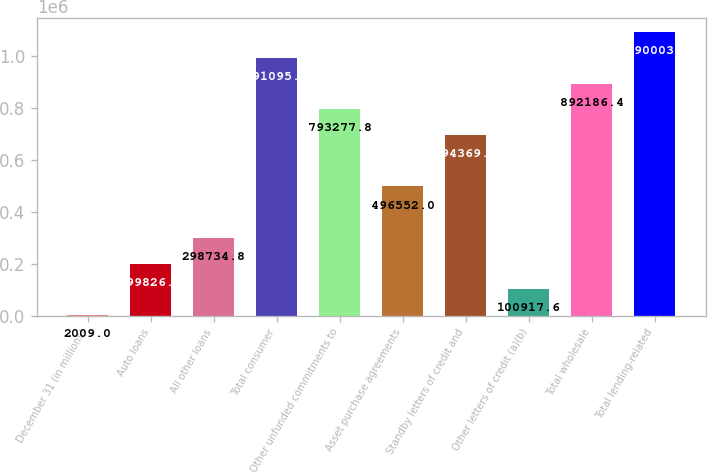Convert chart. <chart><loc_0><loc_0><loc_500><loc_500><bar_chart><fcel>December 31 (in millions)<fcel>Auto loans<fcel>All other loans<fcel>Total consumer<fcel>Other unfunded commitments to<fcel>Asset purchase agreements<fcel>Standby letters of credit and<fcel>Other letters of credit (a)(b)<fcel>Total wholesale<fcel>Total lending-related<nl><fcel>2009<fcel>199826<fcel>298735<fcel>991095<fcel>793278<fcel>496552<fcel>694369<fcel>100918<fcel>892186<fcel>1.09e+06<nl></chart> 